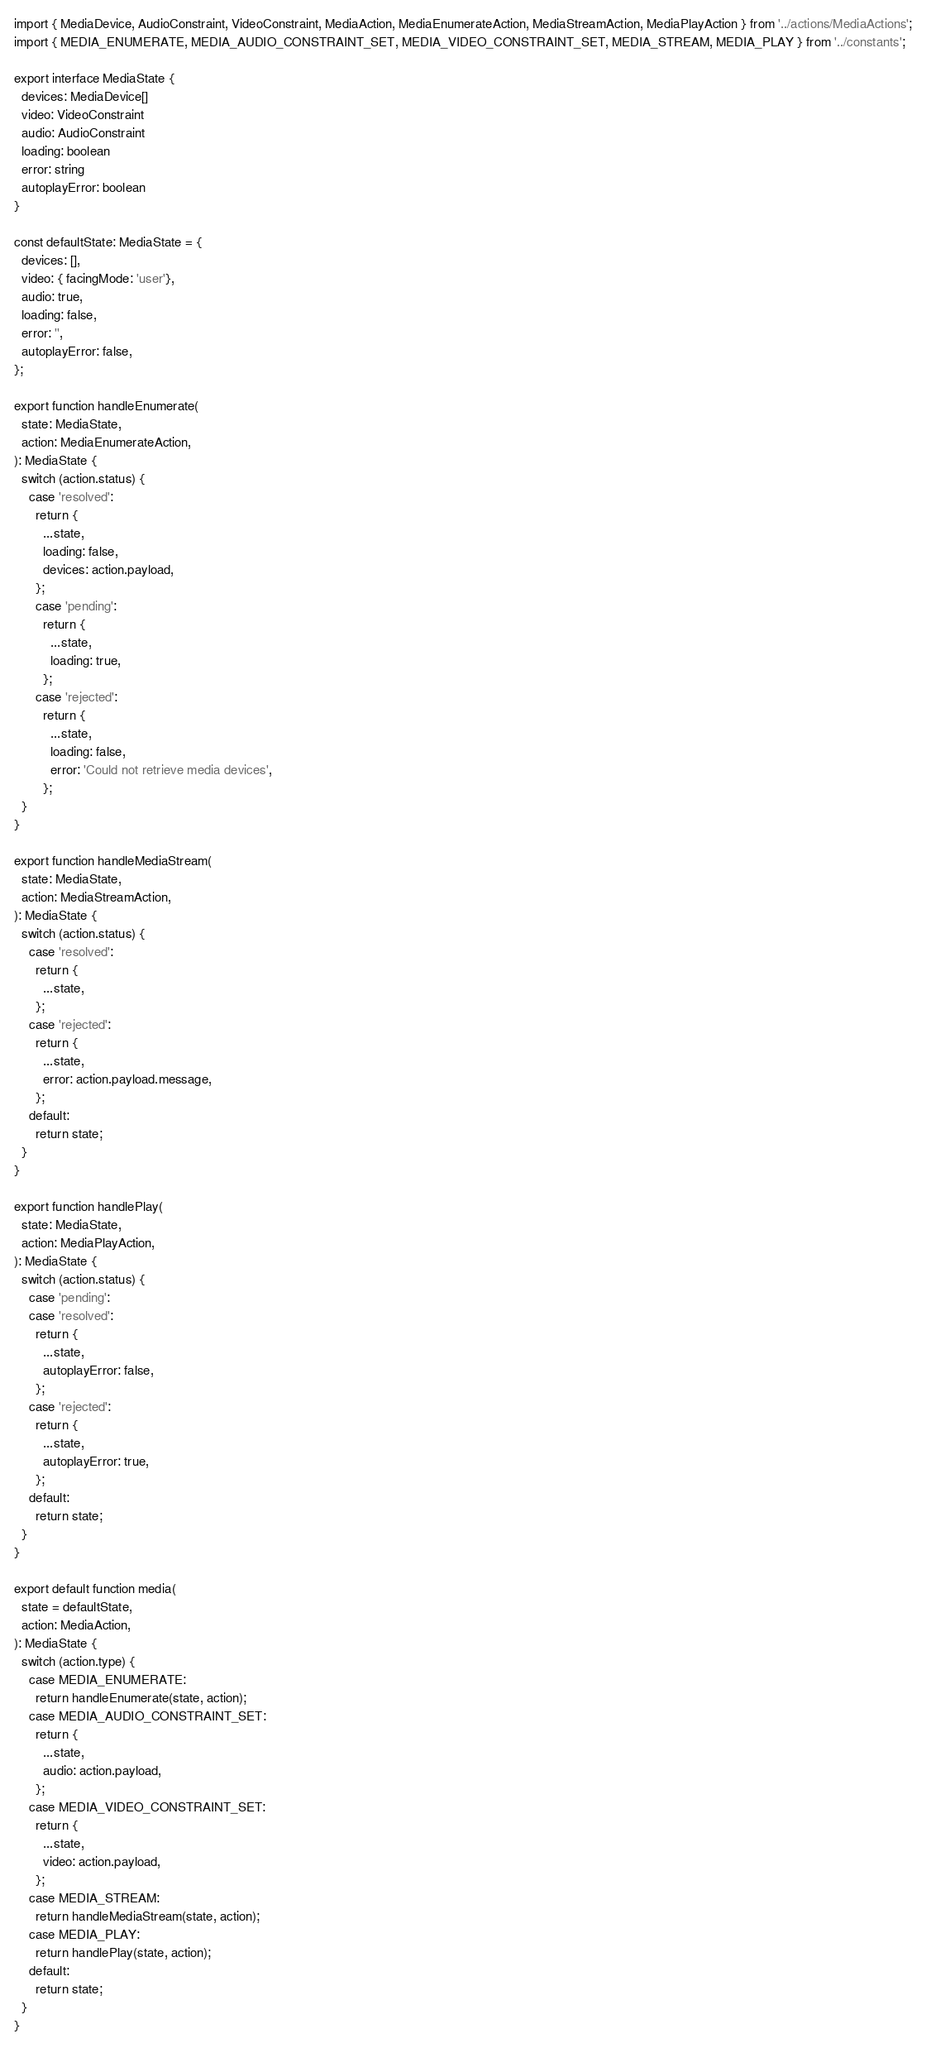<code> <loc_0><loc_0><loc_500><loc_500><_TypeScript_>import { MediaDevice, AudioConstraint, VideoConstraint, MediaAction, MediaEnumerateAction, MediaStreamAction, MediaPlayAction } from '../actions/MediaActions';
import { MEDIA_ENUMERATE, MEDIA_AUDIO_CONSTRAINT_SET, MEDIA_VIDEO_CONSTRAINT_SET, MEDIA_STREAM, MEDIA_PLAY } from '../constants';

export interface MediaState {
  devices: MediaDevice[]
  video: VideoConstraint
  audio: AudioConstraint
  loading: boolean
  error: string
  autoplayError: boolean
}

const defaultState: MediaState = {
  devices: [],
  video: { facingMode: 'user'},
  audio: true,
  loading: false,
  error: '',
  autoplayError: false,
};

export function handleEnumerate(
  state: MediaState,
  action: MediaEnumerateAction,
): MediaState {
  switch (action.status) {
    case 'resolved':
      return {
        ...state,
        loading: false,
        devices: action.payload,
      };
      case 'pending':
        return {
          ...state,
          loading: true,
        };
      case 'rejected':
        return {
          ...state,
          loading: false,
          error: 'Could not retrieve media devices',
        };
  }
}

export function handleMediaStream(
  state: MediaState,
  action: MediaStreamAction,
): MediaState {
  switch (action.status) {
    case 'resolved':
      return {
        ...state,
      };
    case 'rejected':
      return {
        ...state,
        error: action.payload.message,
      };
    default:
      return state;
  }
}

export function handlePlay(
  state: MediaState,
  action: MediaPlayAction,
): MediaState {
  switch (action.status) {
    case 'pending':
    case 'resolved':
      return {
        ...state,
        autoplayError: false,
      };
    case 'rejected':
      return {
        ...state,
        autoplayError: true,
      };
    default:
      return state;
  }
}

export default function media(
  state = defaultState,
  action: MediaAction,
): MediaState {
  switch (action.type) {
    case MEDIA_ENUMERATE:
      return handleEnumerate(state, action);
    case MEDIA_AUDIO_CONSTRAINT_SET:
      return {
        ...state,
        audio: action.payload,
      };
    case MEDIA_VIDEO_CONSTRAINT_SET:
      return {
        ...state,
        video: action.payload,
      };
    case MEDIA_STREAM:
      return handleMediaStream(state, action);
    case MEDIA_PLAY:
      return handlePlay(state, action);
    default:
      return state;
  }
}
</code> 